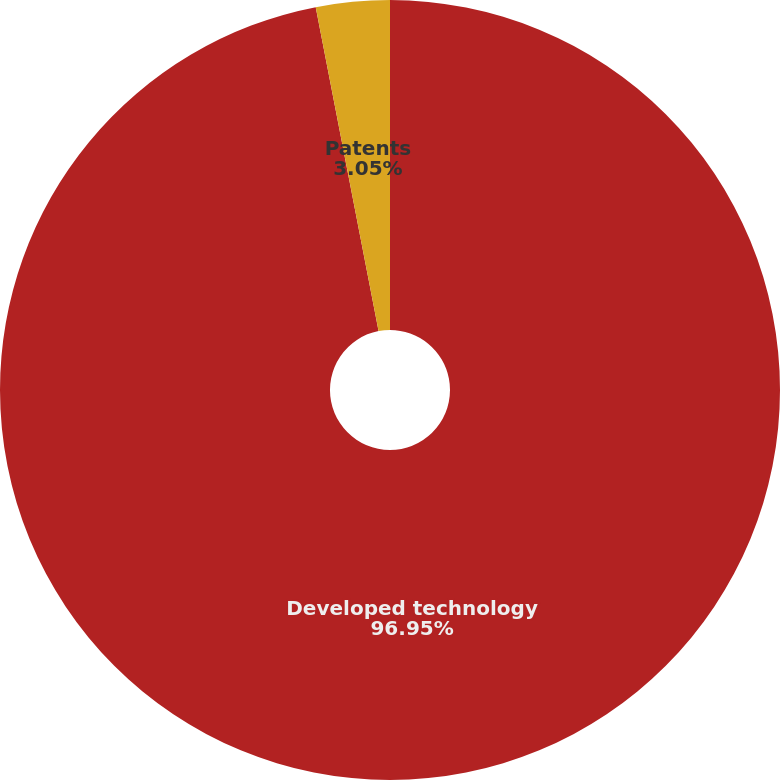Convert chart. <chart><loc_0><loc_0><loc_500><loc_500><pie_chart><fcel>Developed technology<fcel>Patents<nl><fcel>96.95%<fcel>3.05%<nl></chart> 